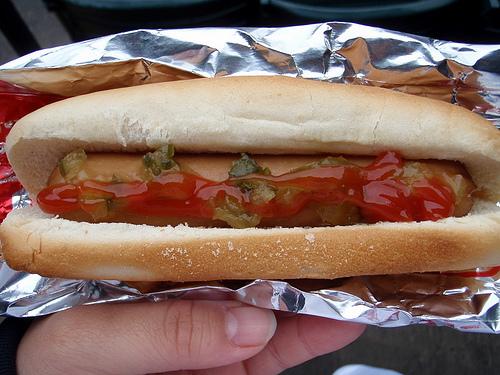Where is the hot dog?
Give a very brief answer. In bun. What type of food is it?
Be succinct. Hot dog. The red stuff is ketchup?
Keep it brief. Yes. What is the red stuff on this food?
Give a very brief answer. Ketchup. 